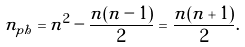Convert formula to latex. <formula><loc_0><loc_0><loc_500><loc_500>n _ { p h } = n ^ { 2 } - \frac { n ( n - 1 ) } { 2 } = \frac { n ( n + 1 ) } { 2 } .</formula> 